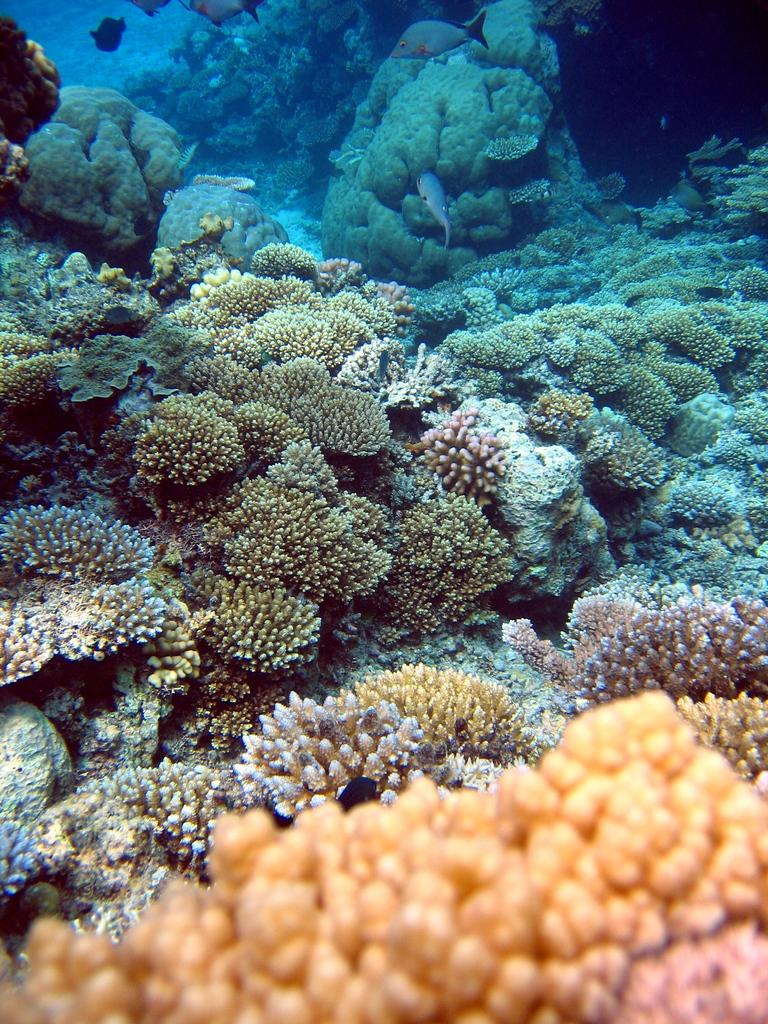What type of marine life can be seen under the water in the image? There are corals and fishes under the water in the image. Can you describe the environment in which the corals and fishes are located? The corals and fishes are located under the water in the image. How does the coral laugh under the water in the image? Corals do not have the ability to laugh, as they are inanimate objects. Can you describe the flying fish in the image? There are no flying fish present in the image; it features corals and fishes under the water. 